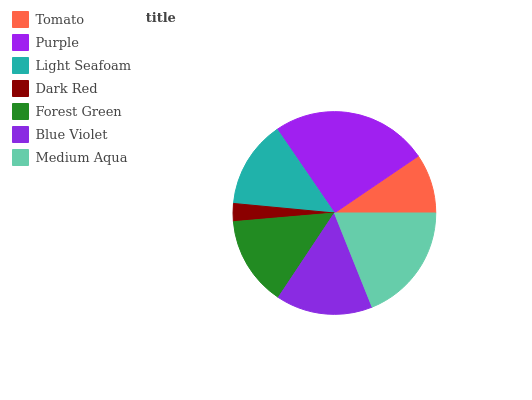Is Dark Red the minimum?
Answer yes or no. Yes. Is Purple the maximum?
Answer yes or no. Yes. Is Light Seafoam the minimum?
Answer yes or no. No. Is Light Seafoam the maximum?
Answer yes or no. No. Is Purple greater than Light Seafoam?
Answer yes or no. Yes. Is Light Seafoam less than Purple?
Answer yes or no. Yes. Is Light Seafoam greater than Purple?
Answer yes or no. No. Is Purple less than Light Seafoam?
Answer yes or no. No. Is Forest Green the high median?
Answer yes or no. Yes. Is Forest Green the low median?
Answer yes or no. Yes. Is Medium Aqua the high median?
Answer yes or no. No. Is Purple the low median?
Answer yes or no. No. 